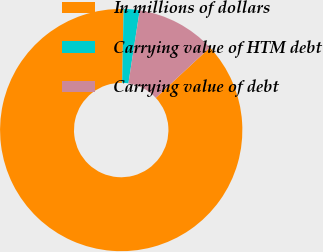Convert chart. <chart><loc_0><loc_0><loc_500><loc_500><pie_chart><fcel>In millions of dollars<fcel>Carrying value of HTM debt<fcel>Carrying value of debt<nl><fcel>87.25%<fcel>2.12%<fcel>10.63%<nl></chart> 